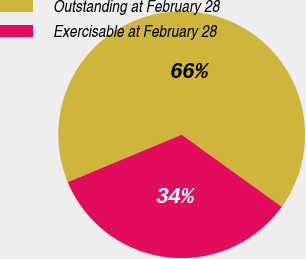Convert chart to OTSL. <chart><loc_0><loc_0><loc_500><loc_500><pie_chart><fcel>Outstanding at February 28<fcel>Exercisable at February 28<nl><fcel>66.21%<fcel>33.79%<nl></chart> 